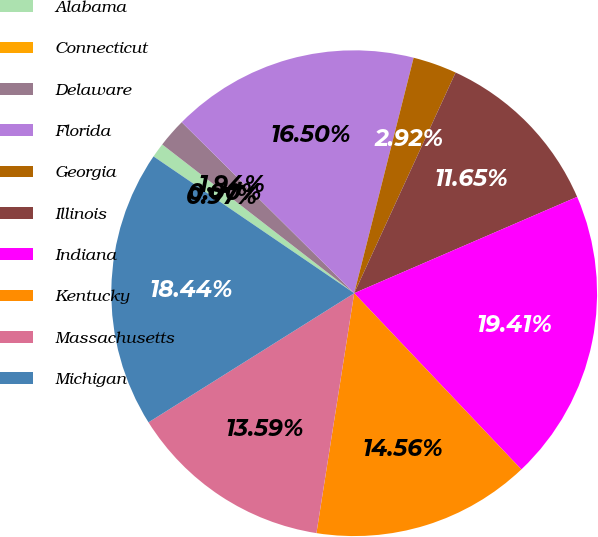Convert chart to OTSL. <chart><loc_0><loc_0><loc_500><loc_500><pie_chart><fcel>Alabama<fcel>Connecticut<fcel>Delaware<fcel>Florida<fcel>Georgia<fcel>Illinois<fcel>Indiana<fcel>Kentucky<fcel>Massachusetts<fcel>Michigan<nl><fcel>0.97%<fcel>0.0%<fcel>1.94%<fcel>16.5%<fcel>2.92%<fcel>11.65%<fcel>19.41%<fcel>14.56%<fcel>13.59%<fcel>18.44%<nl></chart> 